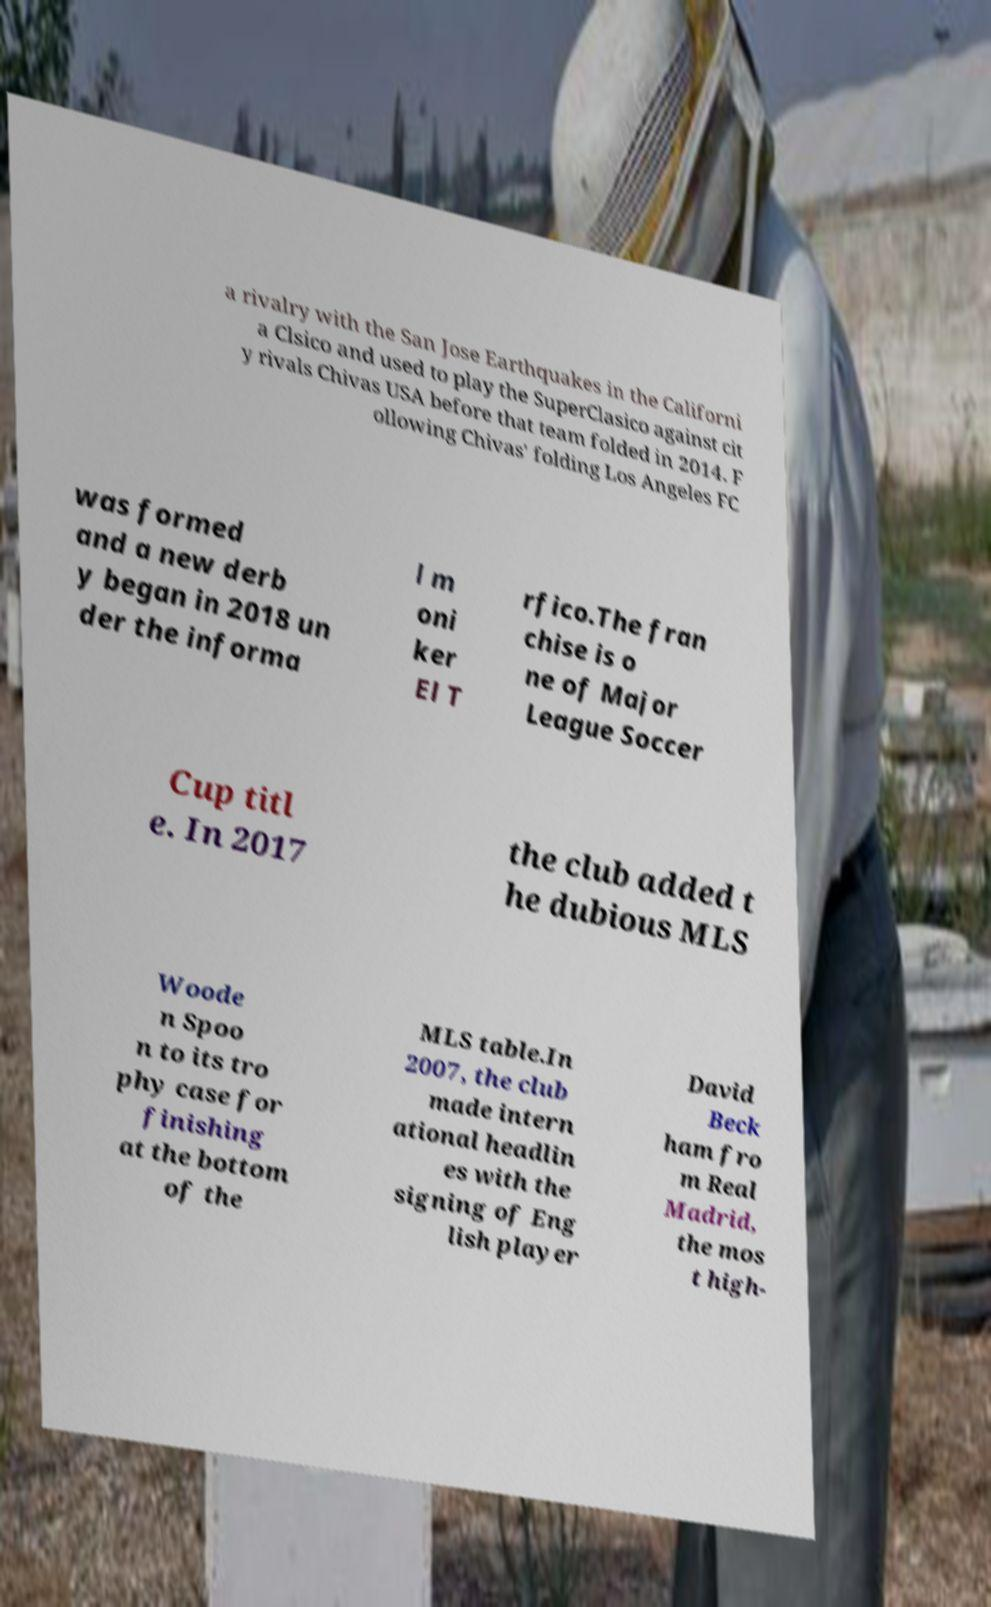For documentation purposes, I need the text within this image transcribed. Could you provide that? a rivalry with the San Jose Earthquakes in the Californi a Clsico and used to play the SuperClasico against cit y rivals Chivas USA before that team folded in 2014. F ollowing Chivas' folding Los Angeles FC was formed and a new derb y began in 2018 un der the informa l m oni ker El T rfico.The fran chise is o ne of Major League Soccer Cup titl e. In 2017 the club added t he dubious MLS Woode n Spoo n to its tro phy case for finishing at the bottom of the MLS table.In 2007, the club made intern ational headlin es with the signing of Eng lish player David Beck ham fro m Real Madrid, the mos t high- 